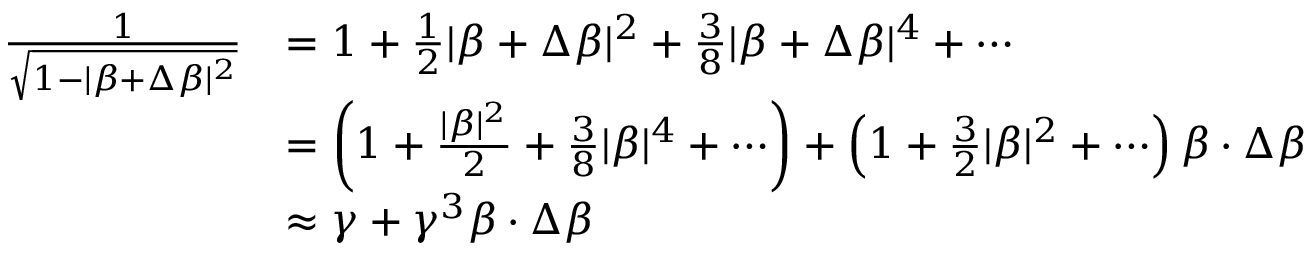<formula> <loc_0><loc_0><loc_500><loc_500>{ \begin{array} { r l } { { \frac { 1 } { \sqrt { 1 - | { \beta } + \Delta { \beta } | ^ { 2 } } } } } & { = 1 + { \frac { 1 } { 2 } } | { \beta } + \Delta { \beta } | ^ { 2 } + { \frac { 3 } { 8 } } | { \beta } + \Delta { \beta } | ^ { 4 } + \cdots } \\ & { = \left ( 1 + { \frac { | { \beta } | ^ { 2 } } { 2 } } + { \frac { 3 } { 8 } } | { \beta } | ^ { 4 } + \cdots \right ) + \left ( 1 + { \frac { 3 } { 2 } } | { \beta } | ^ { 2 } + \cdots \right ) { \beta } \cdot \Delta { \beta } } \\ & { \approx \gamma + \gamma ^ { 3 } { \beta } \cdot \Delta { \beta } } \end{array} }</formula> 